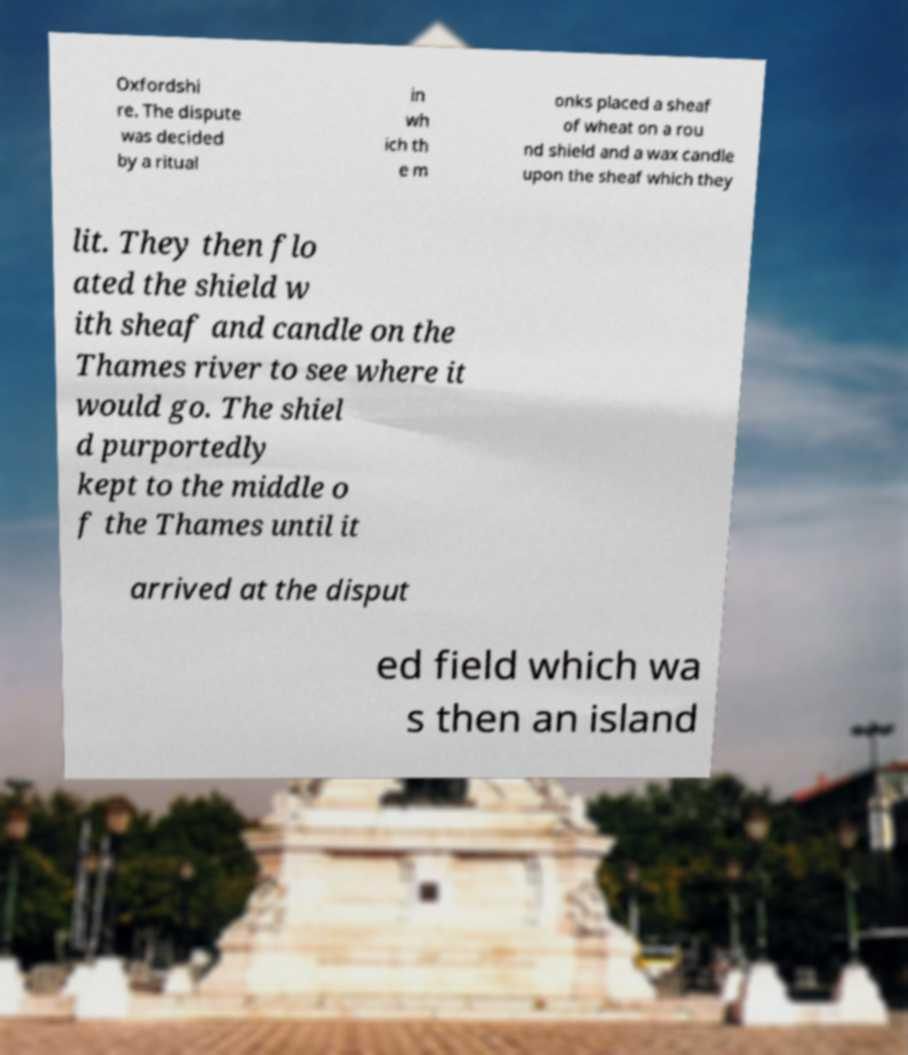Could you extract and type out the text from this image? Oxfordshi re. The dispute was decided by a ritual in wh ich th e m onks placed a sheaf of wheat on a rou nd shield and a wax candle upon the sheaf which they lit. They then flo ated the shield w ith sheaf and candle on the Thames river to see where it would go. The shiel d purportedly kept to the middle o f the Thames until it arrived at the disput ed field which wa s then an island 